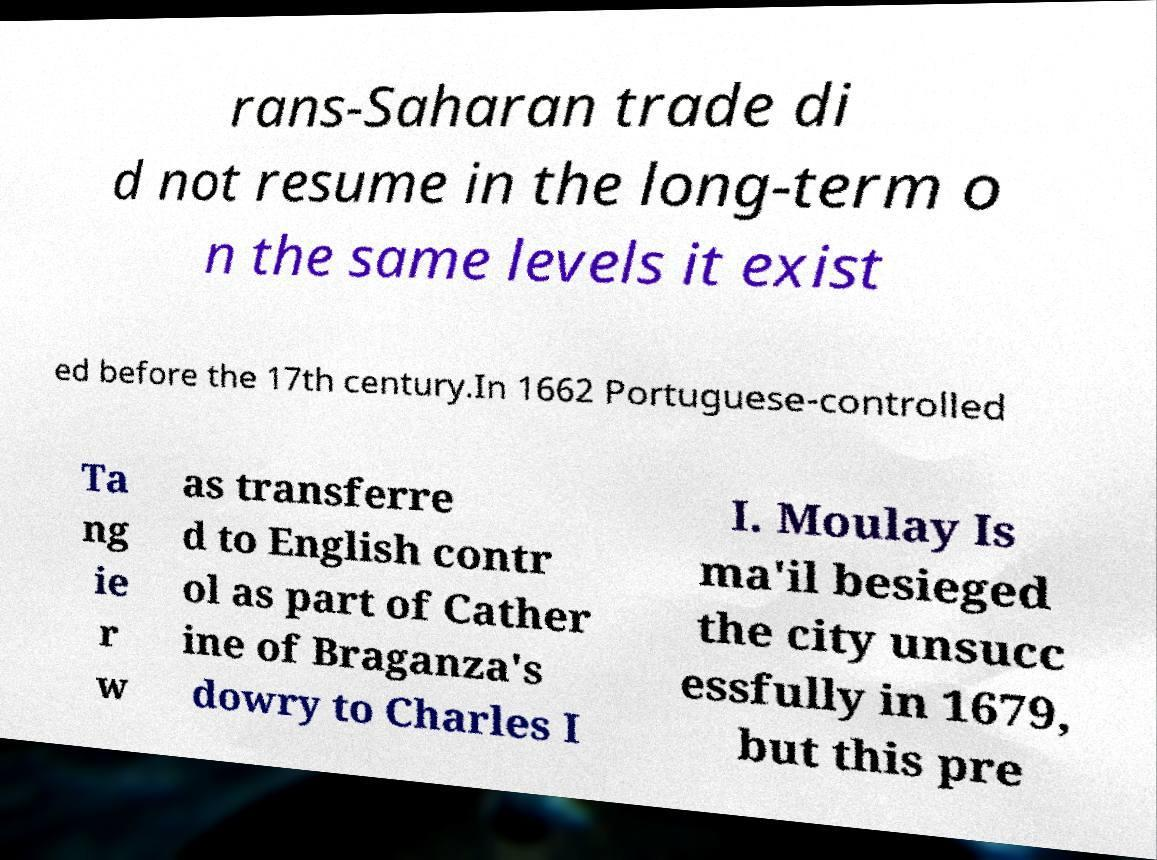Please read and relay the text visible in this image. What does it say? rans-Saharan trade di d not resume in the long-term o n the same levels it exist ed before the 17th century.In 1662 Portuguese-controlled Ta ng ie r w as transferre d to English contr ol as part of Cather ine of Braganza's dowry to Charles I I. Moulay Is ma'il besieged the city unsucc essfully in 1679, but this pre 